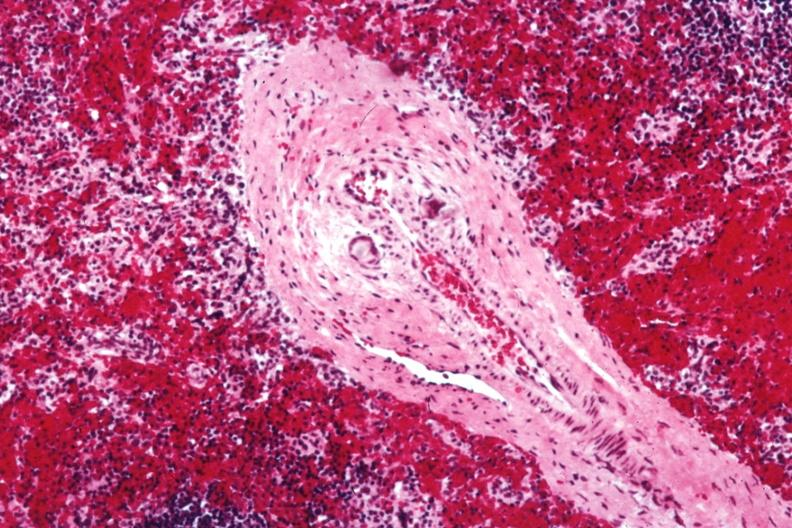what is present?
Answer the question using a single word or phrase. Vasculitis foreign body 